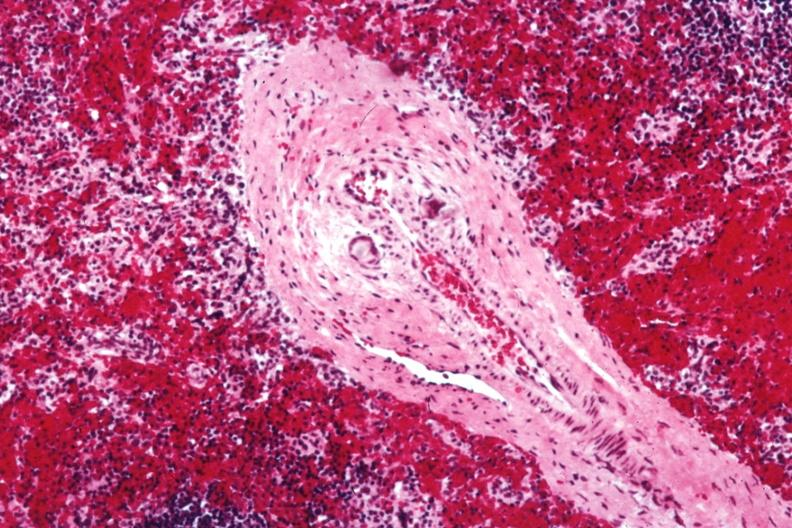what is present?
Answer the question using a single word or phrase. Vasculitis foreign body 